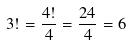<formula> <loc_0><loc_0><loc_500><loc_500>3 ! = \frac { 4 ! } { 4 } = \frac { 2 4 } { 4 } = 6</formula> 